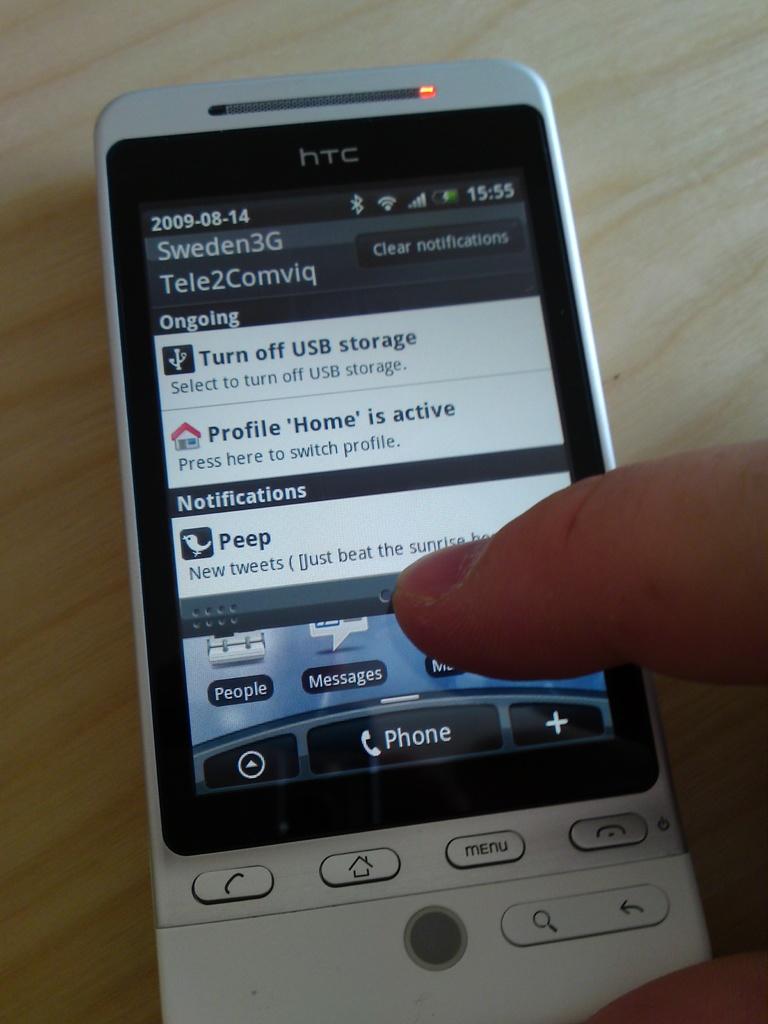Are there any notifications on this phone?
Offer a terse response. Yes. What home country is the user of the in?
Offer a very short reply. Sweden. 